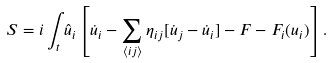<formula> <loc_0><loc_0><loc_500><loc_500>S = i \int _ { t } \hat { u } _ { i } \left [ \dot { u } _ { i } - \sum _ { \langle i j \rangle } \eta _ { i j } [ \dot { u } _ { j } - \dot { u } _ { i } ] - F - F _ { i } ( u _ { i } ) \right ] .</formula> 